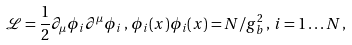Convert formula to latex. <formula><loc_0><loc_0><loc_500><loc_500>\mathcal { L } = \frac { 1 } { 2 } \partial _ { \mu } \phi _ { i } \partial ^ { \mu } \phi _ { i } \, , \, \phi _ { i } ( x ) \phi _ { i } ( x ) = N / g _ { b } ^ { 2 } \, , \, i = 1 \dots N \, ,</formula> 